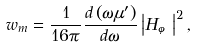Convert formula to latex. <formula><loc_0><loc_0><loc_500><loc_500>w _ { m } = \frac { 1 } { 1 6 \pi } \frac { d \left ( \omega \mu ^ { \prime } \right ) } { d \omega } \left | H _ { \varphi } \right | ^ { 2 } ,</formula> 